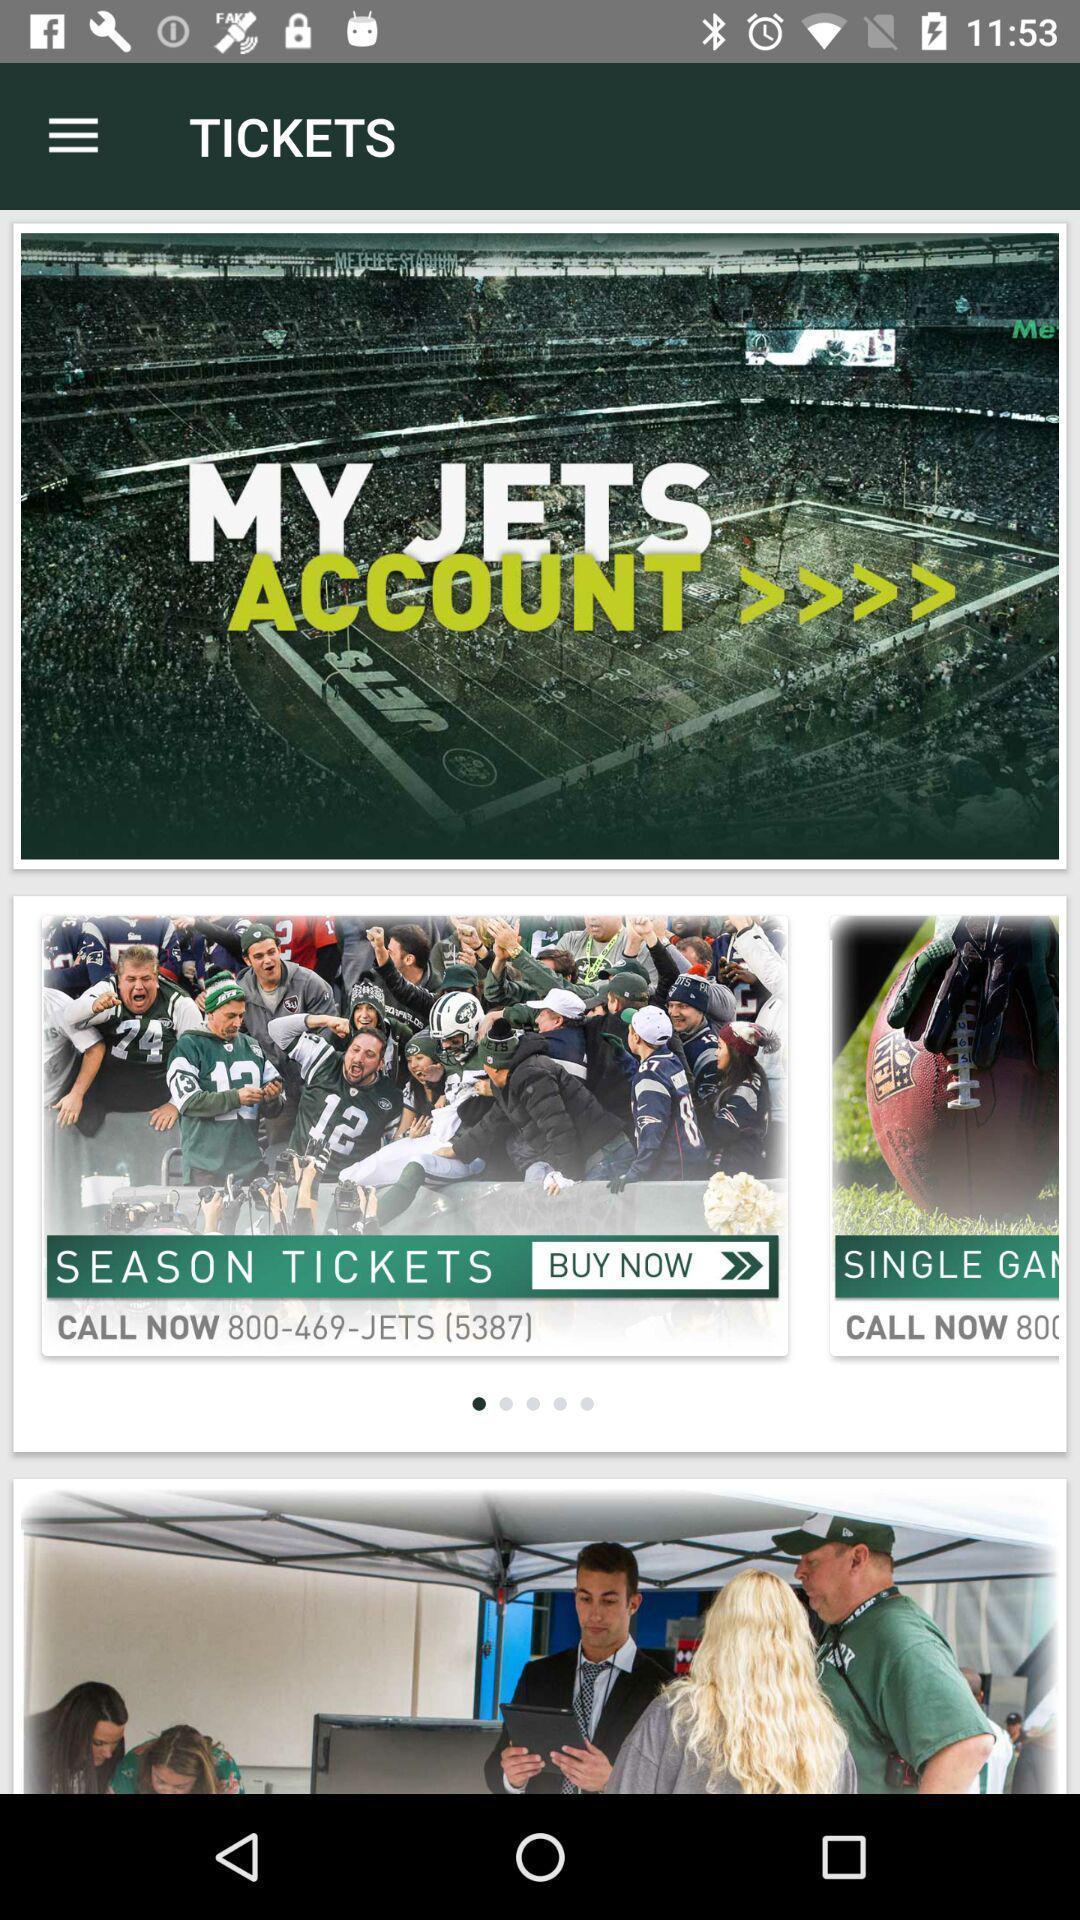What details can you identify in this image? Season tickets in the tickets of the app. 